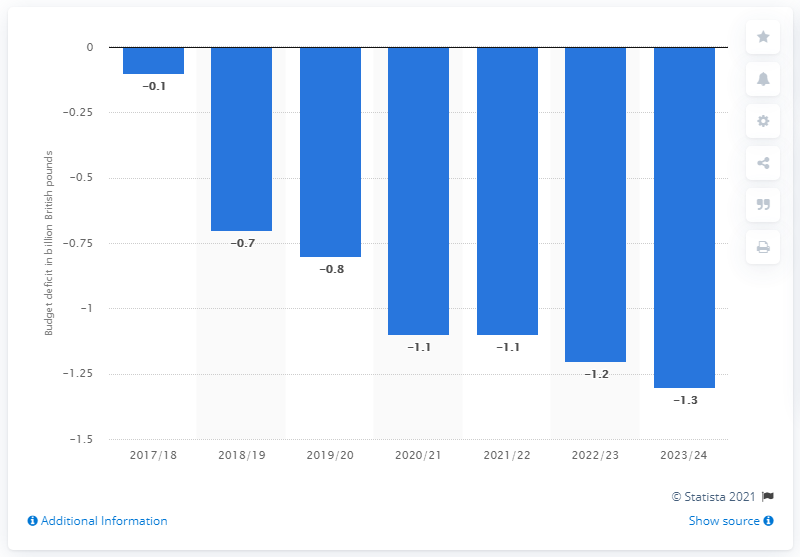Specify some key components in this picture. The current budget deficit of the United Kingdom was in the year 2017/18. The current budget deficit in the United Kingdom is expected to end in the fiscal year 2023/24. 